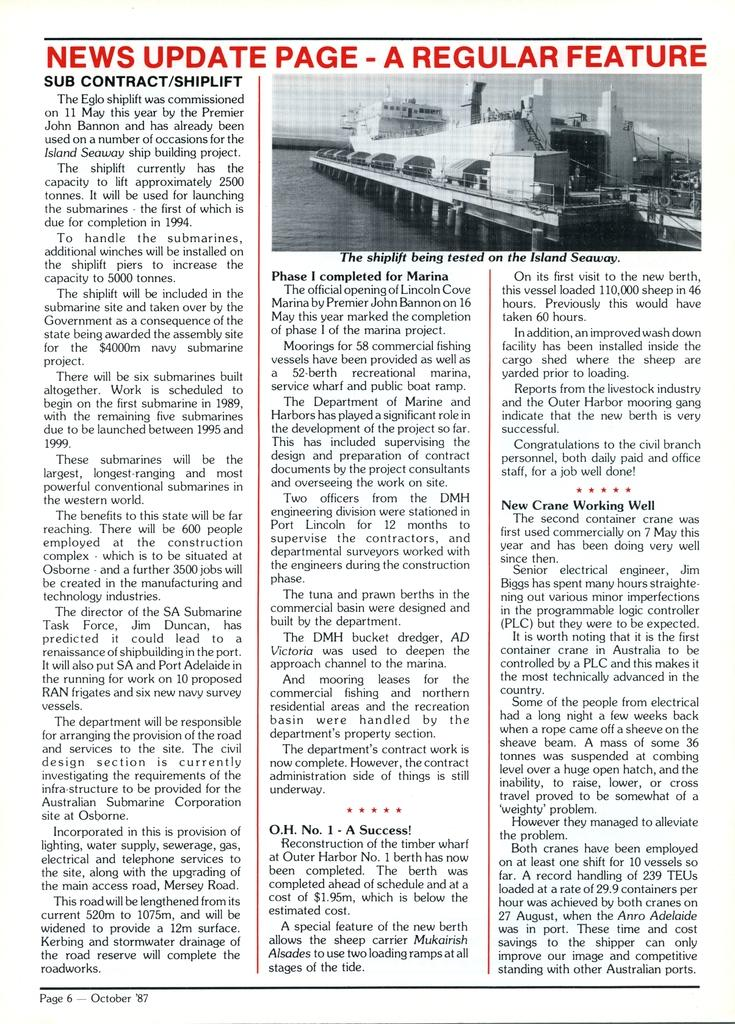<image>
Summarize the visual content of the image. Page from a book which says it is from October 1987. 